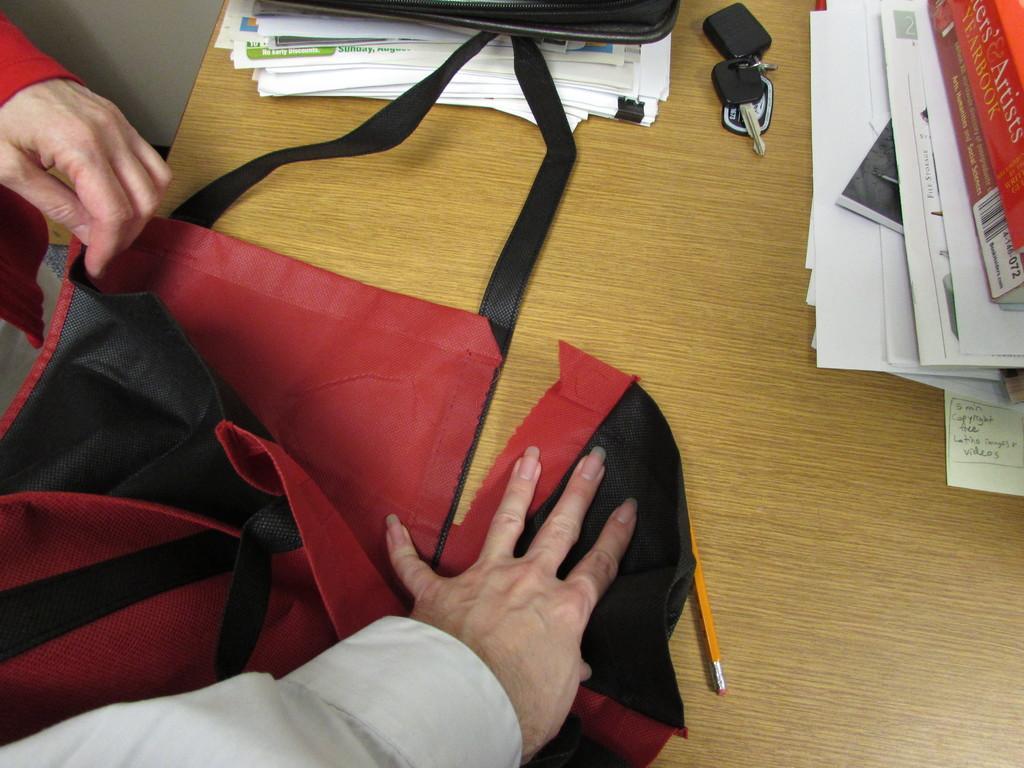Describe this image in one or two sentences. In this picture we can see a person hand on the bag, which is placed on the table, on the table we can see some books, papers and keys. 